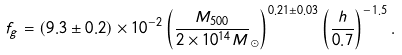<formula> <loc_0><loc_0><loc_500><loc_500>f _ { g } = ( 9 . 3 \pm 0 . 2 ) \times 1 0 ^ { - 2 } \left ( \frac { M _ { 5 0 0 } } { 2 \times 1 0 ^ { 1 4 } M } _ { \odot } \right ) ^ { 0 . 2 1 \pm 0 . 0 3 } \left ( \frac { h } { 0 . 7 } \right ) ^ { - 1 . 5 } .</formula> 